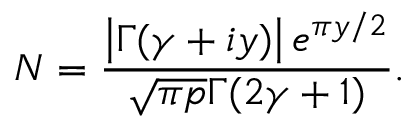<formula> <loc_0><loc_0><loc_500><loc_500>N = \frac { \left | \Gamma ( \gamma + i y ) \right | e ^ { \pi y / 2 } } { \sqrt { \pi p } \Gamma ( 2 \gamma + 1 ) } .</formula> 